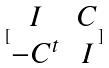<formula> <loc_0><loc_0><loc_500><loc_500>[ \begin{matrix} I & C \\ - C ^ { t } & I \end{matrix} ]</formula> 